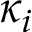Convert formula to latex. <formula><loc_0><loc_0><loc_500><loc_500>\kappa _ { i }</formula> 